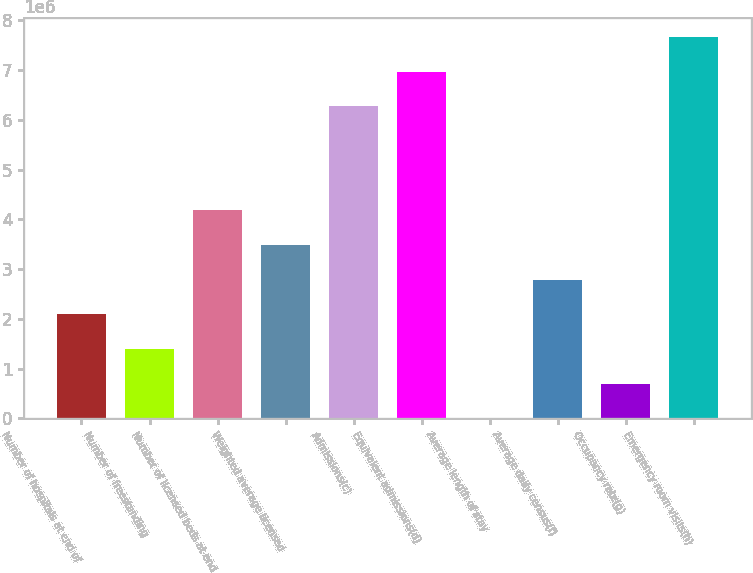<chart> <loc_0><loc_0><loc_500><loc_500><bar_chart><fcel>Number of hospitals at end of<fcel>Number of freestanding<fcel>Number of licensed beds at end<fcel>Weighted average licensed<fcel>Admissions(c)<fcel>Equivalent admissions(d)<fcel>Average length of stay<fcel>Average daily census(f)<fcel>Occupancy rate(g)<fcel>Emergency room visits(h)<nl><fcel>2.09043e+06<fcel>1.39362e+06<fcel>4.18086e+06<fcel>3.48405e+06<fcel>6.27129e+06<fcel>6.9681e+06<fcel>4.8<fcel>2.78724e+06<fcel>696814<fcel>7.66491e+06<nl></chart> 